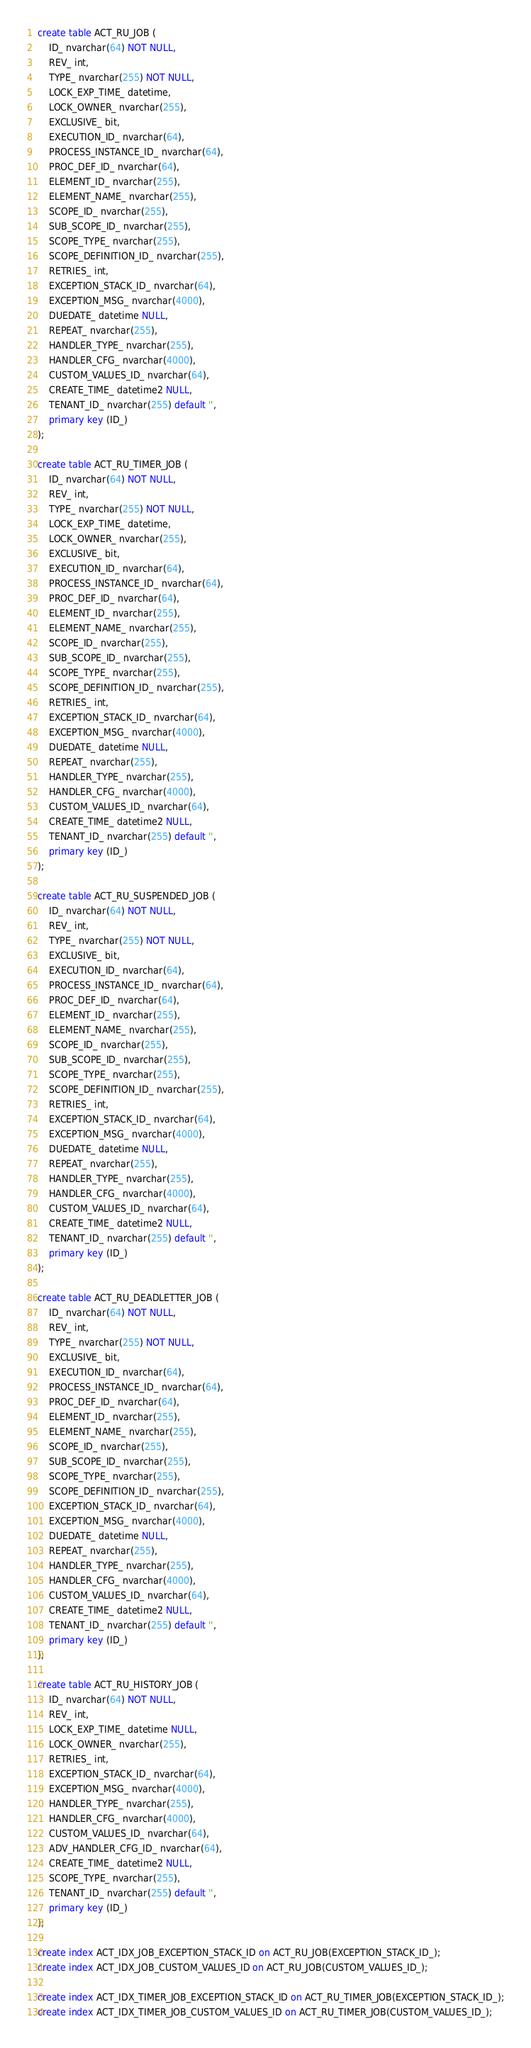<code> <loc_0><loc_0><loc_500><loc_500><_SQL_>create table ACT_RU_JOB (
    ID_ nvarchar(64) NOT NULL,
    REV_ int,
    TYPE_ nvarchar(255) NOT NULL,
    LOCK_EXP_TIME_ datetime,
    LOCK_OWNER_ nvarchar(255),
    EXCLUSIVE_ bit,
    EXECUTION_ID_ nvarchar(64),
    PROCESS_INSTANCE_ID_ nvarchar(64),
    PROC_DEF_ID_ nvarchar(64),
    ELEMENT_ID_ nvarchar(255),
    ELEMENT_NAME_ nvarchar(255),
    SCOPE_ID_ nvarchar(255),
    SUB_SCOPE_ID_ nvarchar(255),
    SCOPE_TYPE_ nvarchar(255),
    SCOPE_DEFINITION_ID_ nvarchar(255),
    RETRIES_ int,
    EXCEPTION_STACK_ID_ nvarchar(64),
    EXCEPTION_MSG_ nvarchar(4000),
    DUEDATE_ datetime NULL,
    REPEAT_ nvarchar(255),
    HANDLER_TYPE_ nvarchar(255),
    HANDLER_CFG_ nvarchar(4000),
    CUSTOM_VALUES_ID_ nvarchar(64),
    CREATE_TIME_ datetime2 NULL,
    TENANT_ID_ nvarchar(255) default '',
    primary key (ID_)
);

create table ACT_RU_TIMER_JOB (
    ID_ nvarchar(64) NOT NULL,
    REV_ int,
    TYPE_ nvarchar(255) NOT NULL,
    LOCK_EXP_TIME_ datetime,
    LOCK_OWNER_ nvarchar(255),
    EXCLUSIVE_ bit,
    EXECUTION_ID_ nvarchar(64),
    PROCESS_INSTANCE_ID_ nvarchar(64),
    PROC_DEF_ID_ nvarchar(64),
    ELEMENT_ID_ nvarchar(255),
    ELEMENT_NAME_ nvarchar(255),
    SCOPE_ID_ nvarchar(255),
    SUB_SCOPE_ID_ nvarchar(255),
    SCOPE_TYPE_ nvarchar(255),
    SCOPE_DEFINITION_ID_ nvarchar(255),
    RETRIES_ int,
    EXCEPTION_STACK_ID_ nvarchar(64),
    EXCEPTION_MSG_ nvarchar(4000),
    DUEDATE_ datetime NULL,
    REPEAT_ nvarchar(255),
    HANDLER_TYPE_ nvarchar(255),
    HANDLER_CFG_ nvarchar(4000),
    CUSTOM_VALUES_ID_ nvarchar(64),
    CREATE_TIME_ datetime2 NULL,
    TENANT_ID_ nvarchar(255) default '',
    primary key (ID_)
);

create table ACT_RU_SUSPENDED_JOB (
    ID_ nvarchar(64) NOT NULL,
    REV_ int,
    TYPE_ nvarchar(255) NOT NULL,
    EXCLUSIVE_ bit,
    EXECUTION_ID_ nvarchar(64),
    PROCESS_INSTANCE_ID_ nvarchar(64),
    PROC_DEF_ID_ nvarchar(64),
    ELEMENT_ID_ nvarchar(255),
    ELEMENT_NAME_ nvarchar(255),
    SCOPE_ID_ nvarchar(255),
    SUB_SCOPE_ID_ nvarchar(255),
    SCOPE_TYPE_ nvarchar(255),
    SCOPE_DEFINITION_ID_ nvarchar(255),
    RETRIES_ int,
    EXCEPTION_STACK_ID_ nvarchar(64),
    EXCEPTION_MSG_ nvarchar(4000),
    DUEDATE_ datetime NULL,
    REPEAT_ nvarchar(255),
    HANDLER_TYPE_ nvarchar(255),
    HANDLER_CFG_ nvarchar(4000),
    CUSTOM_VALUES_ID_ nvarchar(64),
    CREATE_TIME_ datetime2 NULL,
    TENANT_ID_ nvarchar(255) default '',
    primary key (ID_)
);

create table ACT_RU_DEADLETTER_JOB (
    ID_ nvarchar(64) NOT NULL,
    REV_ int,
    TYPE_ nvarchar(255) NOT NULL,
    EXCLUSIVE_ bit,
    EXECUTION_ID_ nvarchar(64),
    PROCESS_INSTANCE_ID_ nvarchar(64),
    PROC_DEF_ID_ nvarchar(64),
    ELEMENT_ID_ nvarchar(255),
    ELEMENT_NAME_ nvarchar(255),
    SCOPE_ID_ nvarchar(255),
    SUB_SCOPE_ID_ nvarchar(255),
    SCOPE_TYPE_ nvarchar(255),
    SCOPE_DEFINITION_ID_ nvarchar(255),
    EXCEPTION_STACK_ID_ nvarchar(64),
    EXCEPTION_MSG_ nvarchar(4000),
    DUEDATE_ datetime NULL,
    REPEAT_ nvarchar(255),
    HANDLER_TYPE_ nvarchar(255),
    HANDLER_CFG_ nvarchar(4000),
    CUSTOM_VALUES_ID_ nvarchar(64),
    CREATE_TIME_ datetime2 NULL,
    TENANT_ID_ nvarchar(255) default '',
    primary key (ID_)
);

create table ACT_RU_HISTORY_JOB (
    ID_ nvarchar(64) NOT NULL,
    REV_ int,
    LOCK_EXP_TIME_ datetime NULL,
    LOCK_OWNER_ nvarchar(255),
    RETRIES_ int,
    EXCEPTION_STACK_ID_ nvarchar(64),
    EXCEPTION_MSG_ nvarchar(4000),
    HANDLER_TYPE_ nvarchar(255),
    HANDLER_CFG_ nvarchar(4000),
    CUSTOM_VALUES_ID_ nvarchar(64),
    ADV_HANDLER_CFG_ID_ nvarchar(64),
    CREATE_TIME_ datetime2 NULL,
    SCOPE_TYPE_ nvarchar(255),
    TENANT_ID_ nvarchar(255) default '',
    primary key (ID_)
);

create index ACT_IDX_JOB_EXCEPTION_STACK_ID on ACT_RU_JOB(EXCEPTION_STACK_ID_);
create index ACT_IDX_JOB_CUSTOM_VALUES_ID on ACT_RU_JOB(CUSTOM_VALUES_ID_);

create index ACT_IDX_TIMER_JOB_EXCEPTION_STACK_ID on ACT_RU_TIMER_JOB(EXCEPTION_STACK_ID_);
create index ACT_IDX_TIMER_JOB_CUSTOM_VALUES_ID on ACT_RU_TIMER_JOB(CUSTOM_VALUES_ID_);
</code> 